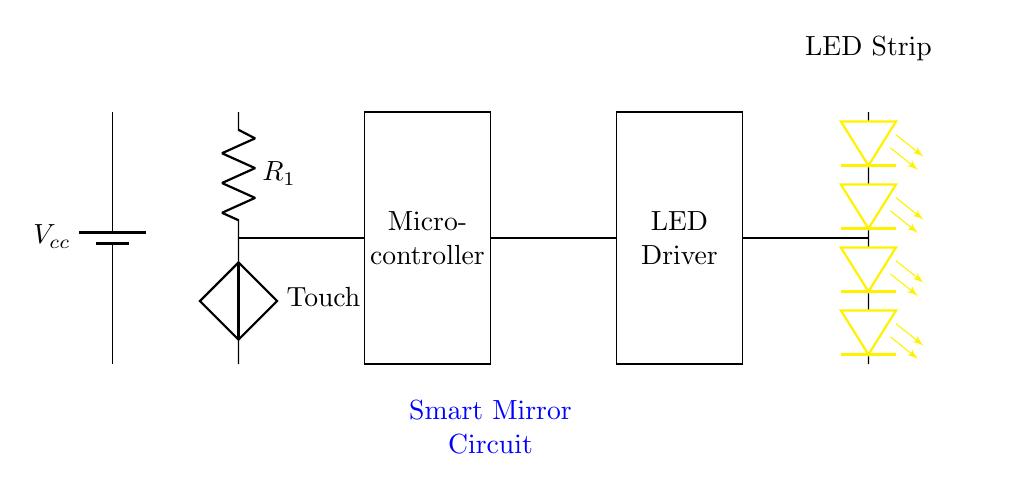What is the function of the touch sensor? The touch sensor in this circuit detects user input through touch, sending a signal to the microcontroller to adjust lighting accordingly.
Answer: user input detection What type of voltage does the circuit use? The battery in this circuit supplies direct current voltage, typically representing the power source for the appliance.
Answer: direct current How many LED strips are connected to the circuit? There are four LED components represented in the circuit, forming the LED strip for adjustable lighting.
Answer: four What component is responsible for controlling the LEDs? The LED driver is specifically designed to regulate the power supplied to the LED strip, allowing for brightness control.
Answer: LED driver How does the microcontroller contribute to the function of the mirror? The microcontroller processes signals from the touch sensor, interpreting them to adjust the lighting of the LEDs based on user commands.
Answer: signal processing What is the role of the resistor in the circuit? The resistor is used to limit the current flowing to the touch sensor, protecting the circuit from excessive current that could lead to damage.
Answer: current limitation 